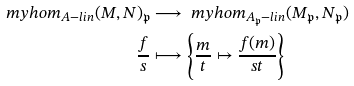Convert formula to latex. <formula><loc_0><loc_0><loc_500><loc_500>\ m y h o m _ { A - l i n } ( M , N ) _ { \mathfrak { p } } & \longrightarrow \ m y h o m _ { A _ { \mathfrak { p } } - l i n } ( M _ { \mathfrak { p } } , N _ { \mathfrak { p } } ) \\ \frac { f } { s } & \longmapsto \left \{ \frac { m } { t } \mapsto \frac { f ( m ) } { s t } \right \}</formula> 